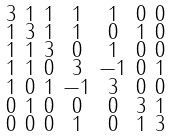Convert formula to latex. <formula><loc_0><loc_0><loc_500><loc_500>\begin{smallmatrix} 3 & 1 & 1 & 1 & 1 & 0 & 0 \\ 1 & 3 & 1 & 1 & 0 & 1 & 0 \\ 1 & 1 & 3 & 0 & 1 & 0 & 0 \\ 1 & 1 & 0 & 3 & - 1 & 0 & 1 \\ 1 & 0 & 1 & - 1 & 3 & 0 & 0 \\ 0 & 1 & 0 & 0 & 0 & 3 & 1 \\ 0 & 0 & 0 & 1 & 0 & 1 & 3 \end{smallmatrix}</formula> 